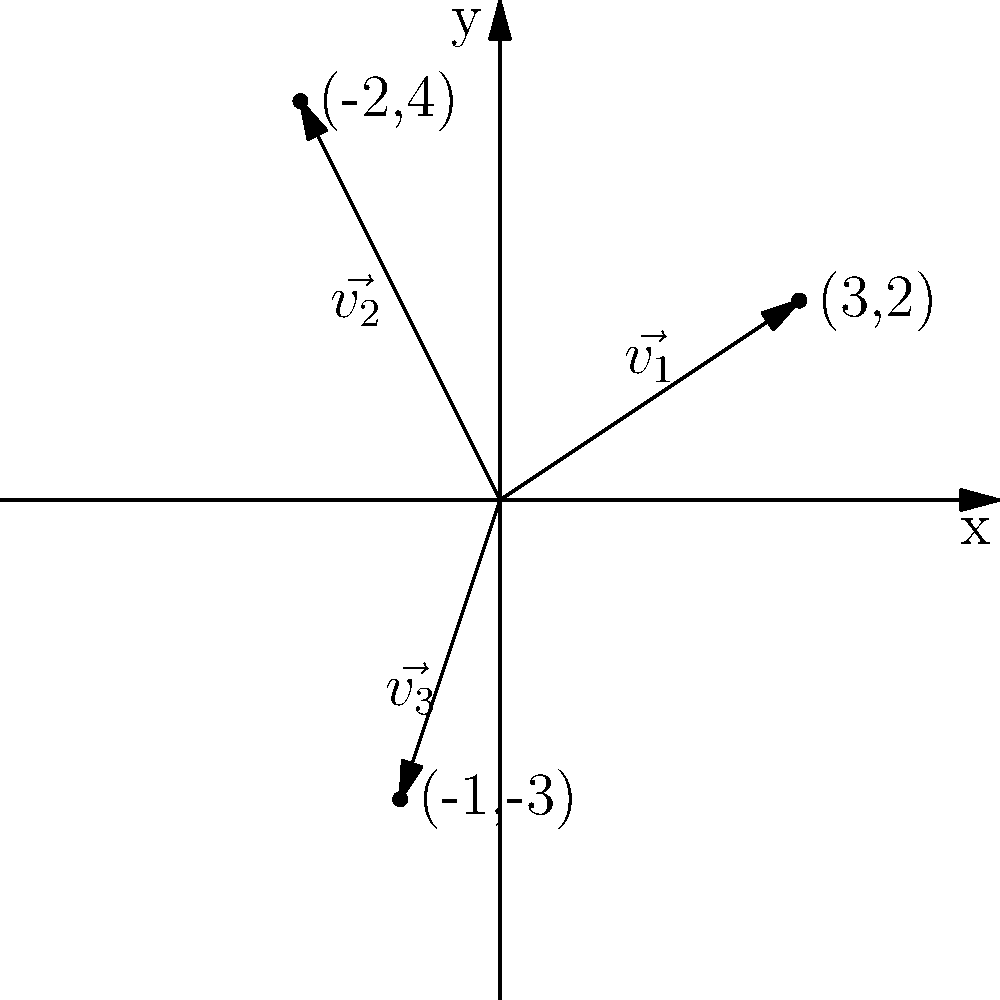As the school council president's advisor, you're helping to represent diverse student opinions on a coordinate plane. Three student groups have expressed their preferences for allocating the school budget, represented by vectors $\vec{v_1}$, $\vec{v_2}$, and $\vec{v_3}$ as shown in the diagram. To find a balanced approach, you decide to calculate the sum of these vectors. What is the resulting vector that represents a compromise among the different student perspectives? To find the sum of the three vectors, we need to add their components:

1. Identify the components of each vector:
   $\vec{v_1} = (3, 2)$
   $\vec{v_2} = (-2, 4)$
   $\vec{v_3} = (-1, -3)$

2. Add the x-components:
   $x_{sum} = 3 + (-2) + (-1) = 0$

3. Add the y-components:
   $y_{sum} = 2 + 4 + (-3) = 3$

4. The resulting vector is the sum of these components:
   $\vec{v}_{sum} = (x_{sum}, y_{sum}) = (0, 3)$

This vector represents a balanced approach that takes into account all three student group perspectives.
Answer: $(0, 3)$ 